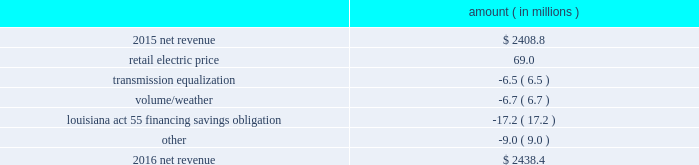Entergy louisiana , llc and subsidiaries management 2019s financial discussion and analysis results of operations net income 2016 compared to 2015 net income increased $ 175.4 million primarily due to the effect of a settlement with the irs related to the 2010-2011 irs audit , which resulted in a $ 136.1 million reduction of income tax expense .
Also contributing to the increase were lower other operation and maintenance expenses , higher net revenue , and higher other income .
The increase was partially offset by higher depreciation and amortization expenses , higher interest expense , and higher nuclear refueling outage expenses .
2015 compared to 2014 net income increased slightly , by $ 0.6 million , primarily due to higher net revenue and a lower effective income tax rate , offset by higher other operation and maintenance expenses , higher depreciation and amortization expenses , lower other income , and higher interest expense .
Net revenue 2016 compared to 2015 net revenue consists of operating revenues net of : 1 ) fuel , fuel-related expenses , and gas purchased for resale , 2 ) purchased power expenses , and 3 ) other regulatory charges .
Following is an analysis of the change in net revenue comparing 2016 to 2015 .
Amount ( in millions ) .
The retail electric price variance is primarily due to an increase in formula rate plan revenues , implemented with the first billing cycle of march 2016 , to collect the estimated first-year revenue requirement related to the purchase of power blocks 3 and 4 of the union power station .
See note 2 to the financial statements for further discussion .
The transmission equalization variance is primarily due to changes in transmission investments , including entergy louisiana 2019s exit from the system agreement in august 2016 .
The volume/weather variance is primarily due to the effect of less favorable weather on residential sales , partially offset by an increase in industrial usage and an increase in volume during the unbilled period .
The increase .
Assuming the retail electric price increase wouldn't have occured , what would 2016 net revenue have been , in millions? 
Computations: (2438.4 - 69.0)
Answer: 2369.4. 